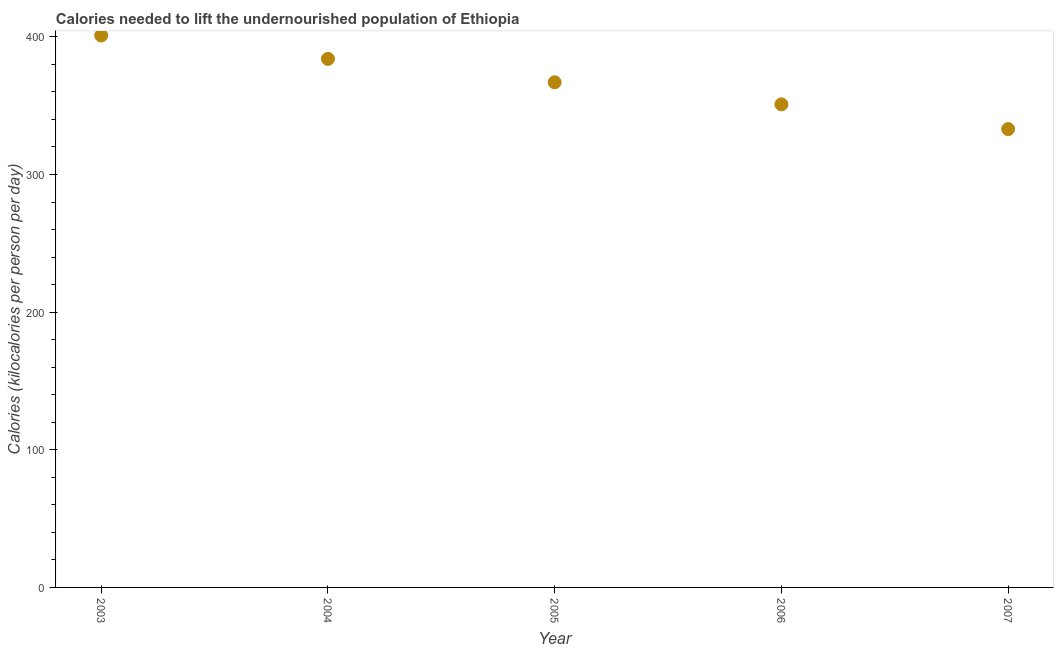What is the depth of food deficit in 2003?
Provide a succinct answer. 401. Across all years, what is the maximum depth of food deficit?
Provide a short and direct response. 401. Across all years, what is the minimum depth of food deficit?
Your answer should be very brief. 333. In which year was the depth of food deficit maximum?
Your answer should be very brief. 2003. In which year was the depth of food deficit minimum?
Offer a terse response. 2007. What is the sum of the depth of food deficit?
Keep it short and to the point. 1836. What is the difference between the depth of food deficit in 2006 and 2007?
Your answer should be compact. 18. What is the average depth of food deficit per year?
Give a very brief answer. 367.2. What is the median depth of food deficit?
Make the answer very short. 367. Do a majority of the years between 2005 and 2007 (inclusive) have depth of food deficit greater than 280 kilocalories?
Provide a short and direct response. Yes. What is the ratio of the depth of food deficit in 2003 to that in 2007?
Your answer should be compact. 1.2. Is the depth of food deficit in 2004 less than that in 2007?
Ensure brevity in your answer.  No. What is the difference between the highest and the second highest depth of food deficit?
Provide a short and direct response. 17. What is the difference between the highest and the lowest depth of food deficit?
Provide a succinct answer. 68. Does the depth of food deficit monotonically increase over the years?
Make the answer very short. No. How many dotlines are there?
Your response must be concise. 1. How many years are there in the graph?
Your response must be concise. 5. Does the graph contain grids?
Your answer should be very brief. No. What is the title of the graph?
Make the answer very short. Calories needed to lift the undernourished population of Ethiopia. What is the label or title of the X-axis?
Your response must be concise. Year. What is the label or title of the Y-axis?
Offer a very short reply. Calories (kilocalories per person per day). What is the Calories (kilocalories per person per day) in 2003?
Ensure brevity in your answer.  401. What is the Calories (kilocalories per person per day) in 2004?
Your answer should be very brief. 384. What is the Calories (kilocalories per person per day) in 2005?
Offer a terse response. 367. What is the Calories (kilocalories per person per day) in 2006?
Your answer should be very brief. 351. What is the Calories (kilocalories per person per day) in 2007?
Your answer should be compact. 333. What is the difference between the Calories (kilocalories per person per day) in 2003 and 2005?
Offer a terse response. 34. What is the difference between the Calories (kilocalories per person per day) in 2004 and 2005?
Your response must be concise. 17. What is the difference between the Calories (kilocalories per person per day) in 2004 and 2006?
Your answer should be very brief. 33. What is the difference between the Calories (kilocalories per person per day) in 2005 and 2006?
Offer a terse response. 16. What is the difference between the Calories (kilocalories per person per day) in 2006 and 2007?
Keep it short and to the point. 18. What is the ratio of the Calories (kilocalories per person per day) in 2003 to that in 2004?
Provide a succinct answer. 1.04. What is the ratio of the Calories (kilocalories per person per day) in 2003 to that in 2005?
Ensure brevity in your answer.  1.09. What is the ratio of the Calories (kilocalories per person per day) in 2003 to that in 2006?
Make the answer very short. 1.14. What is the ratio of the Calories (kilocalories per person per day) in 2003 to that in 2007?
Provide a short and direct response. 1.2. What is the ratio of the Calories (kilocalories per person per day) in 2004 to that in 2005?
Offer a terse response. 1.05. What is the ratio of the Calories (kilocalories per person per day) in 2004 to that in 2006?
Your answer should be compact. 1.09. What is the ratio of the Calories (kilocalories per person per day) in 2004 to that in 2007?
Provide a short and direct response. 1.15. What is the ratio of the Calories (kilocalories per person per day) in 2005 to that in 2006?
Keep it short and to the point. 1.05. What is the ratio of the Calories (kilocalories per person per day) in 2005 to that in 2007?
Your answer should be compact. 1.1. What is the ratio of the Calories (kilocalories per person per day) in 2006 to that in 2007?
Your response must be concise. 1.05. 